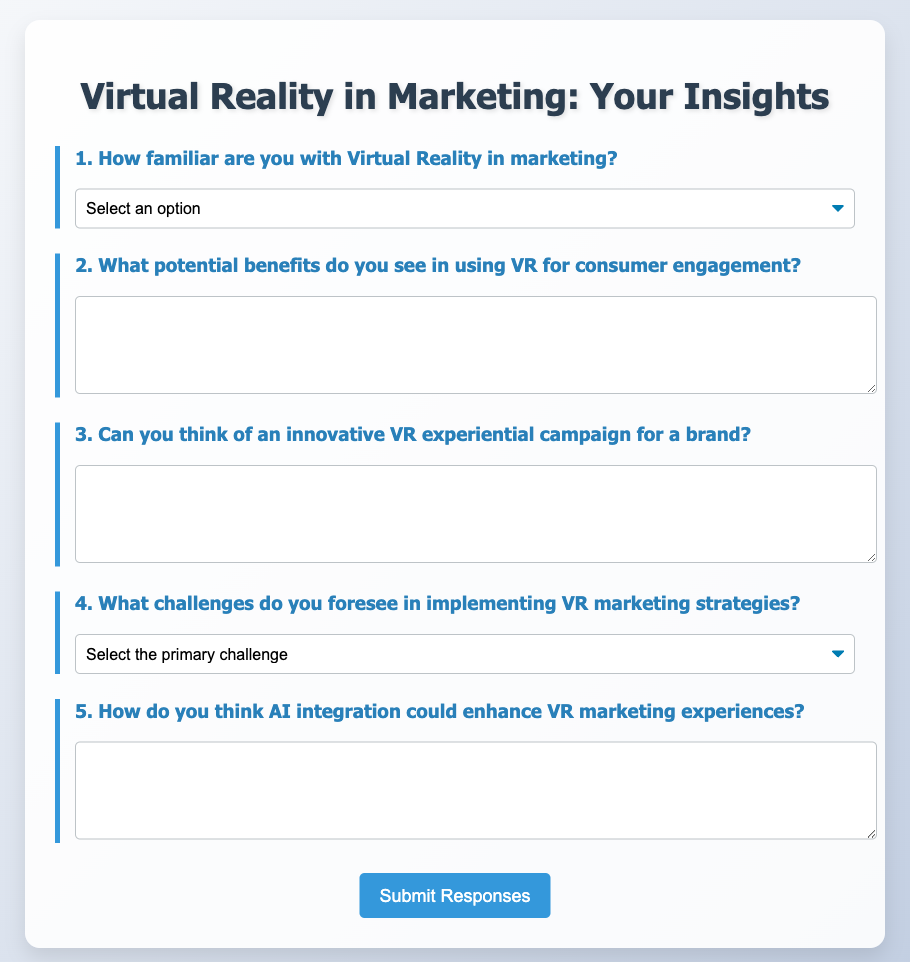What is the title of the document? The title of the document is displayed in the header section of the questionnaire, which is "Virtual Reality in Marketing: Your Insights."
Answer: Virtual Reality in Marketing: Your Insights How many main questions are presented in the questionnaire? The main questions are numbered in the document, indicating how many there are, which is five.
Answer: 5 What type of user experience does the questionnaire ask about in question 1? Question 1 specifically asks about familiarity with Virtual Reality in marketing, which pertains to user experience and knowledge.
Answer: familiarity What is the first option provided for question 4 regarding challenges? The first option listed in question 4 refers to the primary challenges in implementing VR marketing strategies, which is "High costs."
Answer: High costs What does question 5 inquire about regarding the integration of technology? Question 5 asks how AI integration could enhance VR marketing experiences, reflecting on the potential synergy of these technologies.
Answer: AI integration 